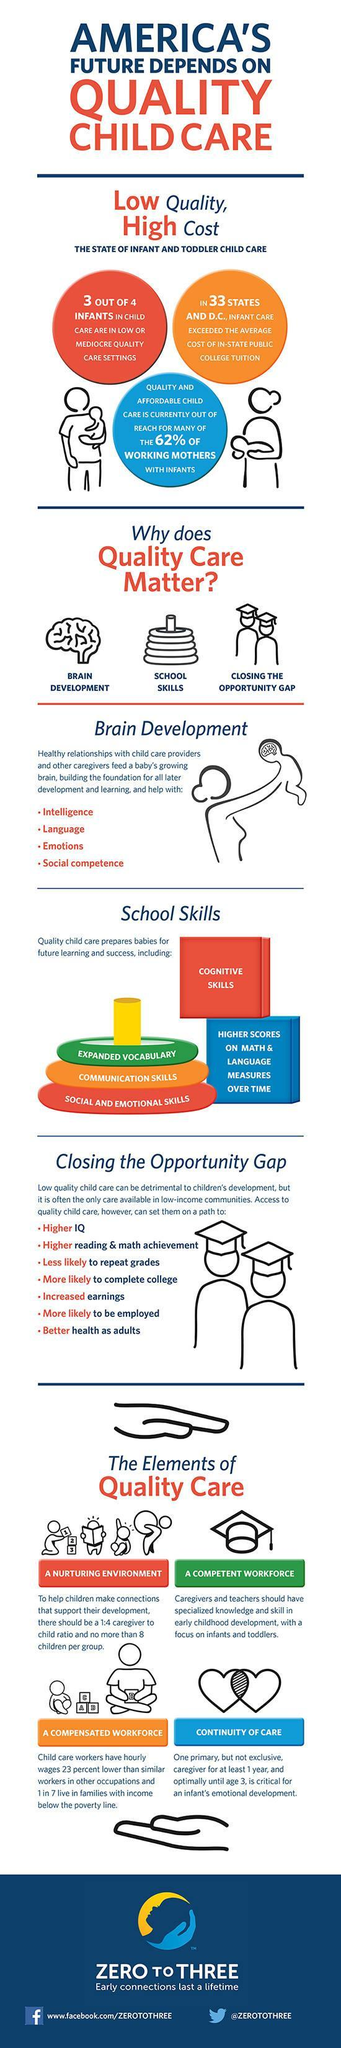What is the Twitter handle mentioned?
Answer the question with a short phrase. @ZEROTOTHREE What are the reasons to provide Quality Care to children? BRAIN DEVELOPMENT, SCHOOL SKILLS, CLOSING THE OPPORTUNITY GAP 